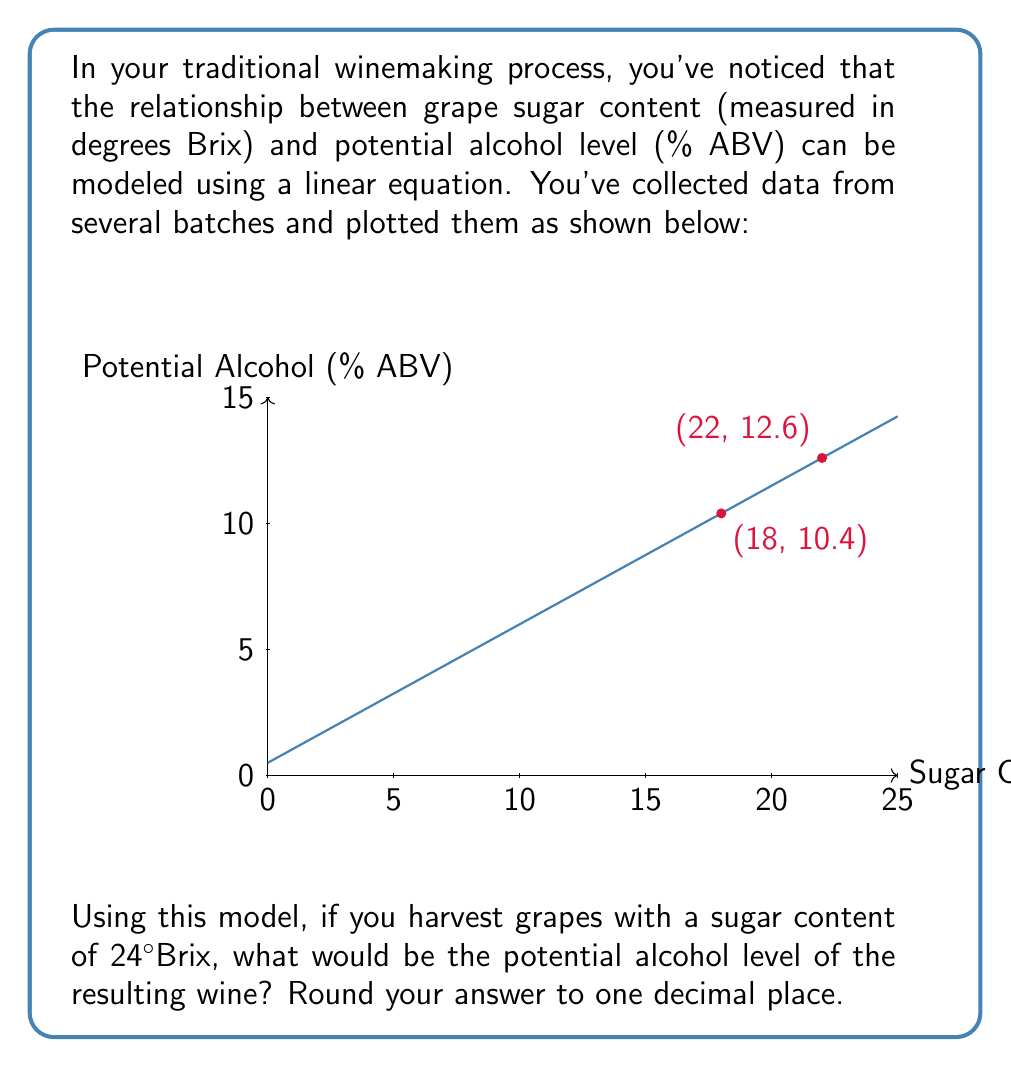Show me your answer to this math problem. Let's approach this step-by-step:

1) We can see that the relationship between sugar content (x) and potential alcohol level (y) is linear. We can use the point-slope form of a line to find the equation:

   $y - y_1 = m(x - x_1)$

2) To find the slope (m), we can use two points from the graph:
   (18, 10.4) and (22, 12.6)

   $m = \frac{y_2 - y_1}{x_2 - x_1} = \frac{12.6 - 10.4}{22 - 18} = \frac{2.2}{4} = 0.55$

3) Now we can use either point to find the equation. Let's use (18, 10.4):

   $y - 10.4 = 0.55(x - 18)$

4) Simplify:
   $y = 0.55x - 9.9 + 10.4$
   $y = 0.55x + 0.5$

5) This is our model equation. To find the potential alcohol level for grapes with 24°Brix, we substitute x = 24:

   $y = 0.55(24) + 0.5$
   $y = 13.2 + 0.5$
   $y = 13.7$

6) Rounding to one decimal place:
   $y ≈ 13.7\% \text{ ABV}$
Answer: 13.7% ABV 